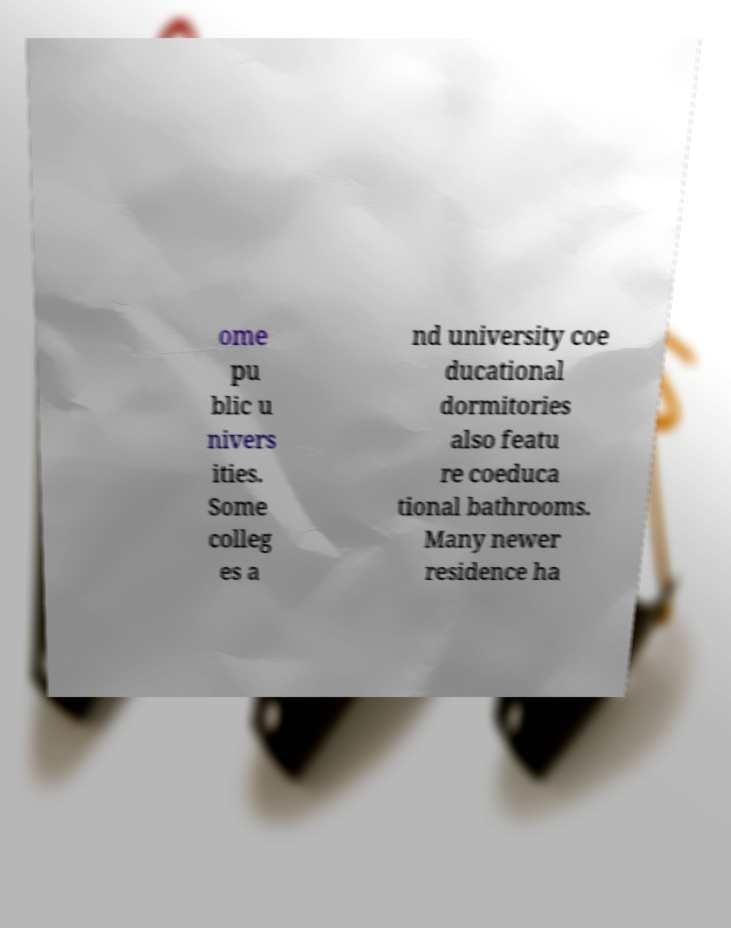For documentation purposes, I need the text within this image transcribed. Could you provide that? ome pu blic u nivers ities. Some colleg es a nd university coe ducational dormitories also featu re coeduca tional bathrooms. Many newer residence ha 